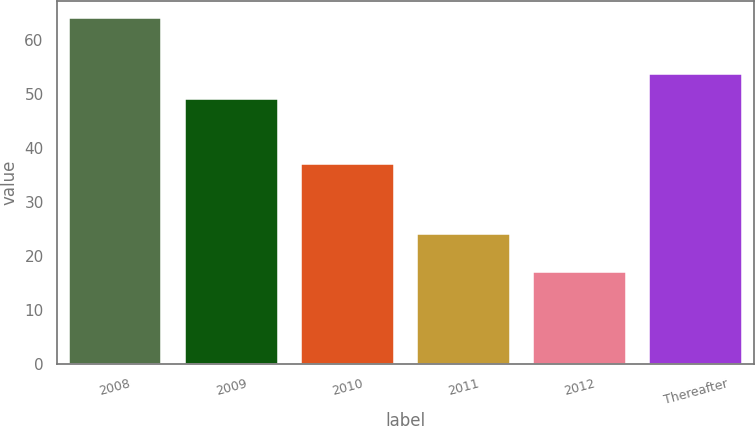Convert chart. <chart><loc_0><loc_0><loc_500><loc_500><bar_chart><fcel>2008<fcel>2009<fcel>2010<fcel>2011<fcel>2012<fcel>Thereafter<nl><fcel>64<fcel>49<fcel>37<fcel>24<fcel>17<fcel>53.7<nl></chart> 